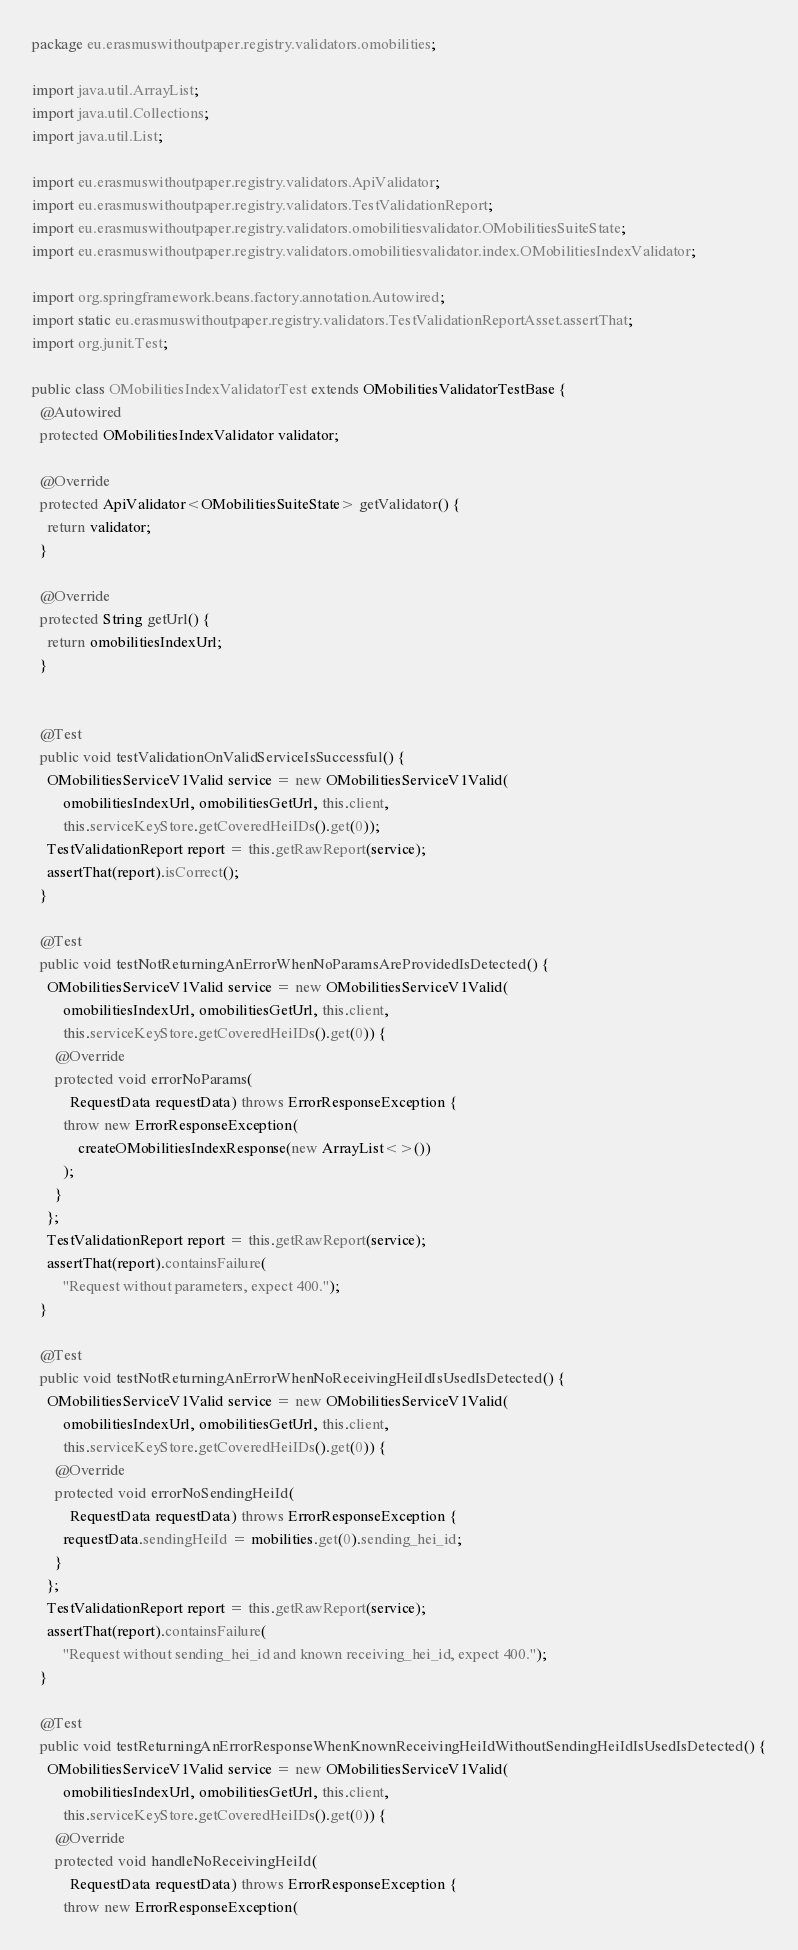<code> <loc_0><loc_0><loc_500><loc_500><_Java_>package eu.erasmuswithoutpaper.registry.validators.omobilities;

import java.util.ArrayList;
import java.util.Collections;
import java.util.List;

import eu.erasmuswithoutpaper.registry.validators.ApiValidator;
import eu.erasmuswithoutpaper.registry.validators.TestValidationReport;
import eu.erasmuswithoutpaper.registry.validators.omobilitiesvalidator.OMobilitiesSuiteState;
import eu.erasmuswithoutpaper.registry.validators.omobilitiesvalidator.index.OMobilitiesIndexValidator;

import org.springframework.beans.factory.annotation.Autowired;
import static eu.erasmuswithoutpaper.registry.validators.TestValidationReportAsset.assertThat;
import org.junit.Test;

public class OMobilitiesIndexValidatorTest extends OMobilitiesValidatorTestBase {
  @Autowired
  protected OMobilitiesIndexValidator validator;

  @Override
  protected ApiValidator<OMobilitiesSuiteState> getValidator() {
    return validator;
  }

  @Override
  protected String getUrl() {
    return omobilitiesIndexUrl;
  }


  @Test
  public void testValidationOnValidServiceIsSuccessful() {
    OMobilitiesServiceV1Valid service = new OMobilitiesServiceV1Valid(
        omobilitiesIndexUrl, omobilitiesGetUrl, this.client,
        this.serviceKeyStore.getCoveredHeiIDs().get(0));
    TestValidationReport report = this.getRawReport(service);
    assertThat(report).isCorrect();
  }

  @Test
  public void testNotReturningAnErrorWhenNoParamsAreProvidedIsDetected() {
    OMobilitiesServiceV1Valid service = new OMobilitiesServiceV1Valid(
        omobilitiesIndexUrl, omobilitiesGetUrl, this.client,
        this.serviceKeyStore.getCoveredHeiIDs().get(0)) {
      @Override
      protected void errorNoParams(
          RequestData requestData) throws ErrorResponseException {
        throw new ErrorResponseException(
            createOMobilitiesIndexResponse(new ArrayList<>())
        );
      }
    };
    TestValidationReport report = this.getRawReport(service);
    assertThat(report).containsFailure(
        "Request without parameters, expect 400.");
  }

  @Test
  public void testNotReturningAnErrorWhenNoReceivingHeiIdIsUsedIsDetected() {
    OMobilitiesServiceV1Valid service = new OMobilitiesServiceV1Valid(
        omobilitiesIndexUrl, omobilitiesGetUrl, this.client,
        this.serviceKeyStore.getCoveredHeiIDs().get(0)) {
      @Override
      protected void errorNoSendingHeiId(
          RequestData requestData) throws ErrorResponseException {
        requestData.sendingHeiId = mobilities.get(0).sending_hei_id;
      }
    };
    TestValidationReport report = this.getRawReport(service);
    assertThat(report).containsFailure(
        "Request without sending_hei_id and known receiving_hei_id, expect 400.");
  }

  @Test
  public void testReturningAnErrorResponseWhenKnownReceivingHeiIdWithoutSendingHeiIdIsUsedIsDetected() {
    OMobilitiesServiceV1Valid service = new OMobilitiesServiceV1Valid(
        omobilitiesIndexUrl, omobilitiesGetUrl, this.client,
        this.serviceKeyStore.getCoveredHeiIDs().get(0)) {
      @Override
      protected void handleNoReceivingHeiId(
          RequestData requestData) throws ErrorResponseException {
        throw new ErrorResponseException(</code> 